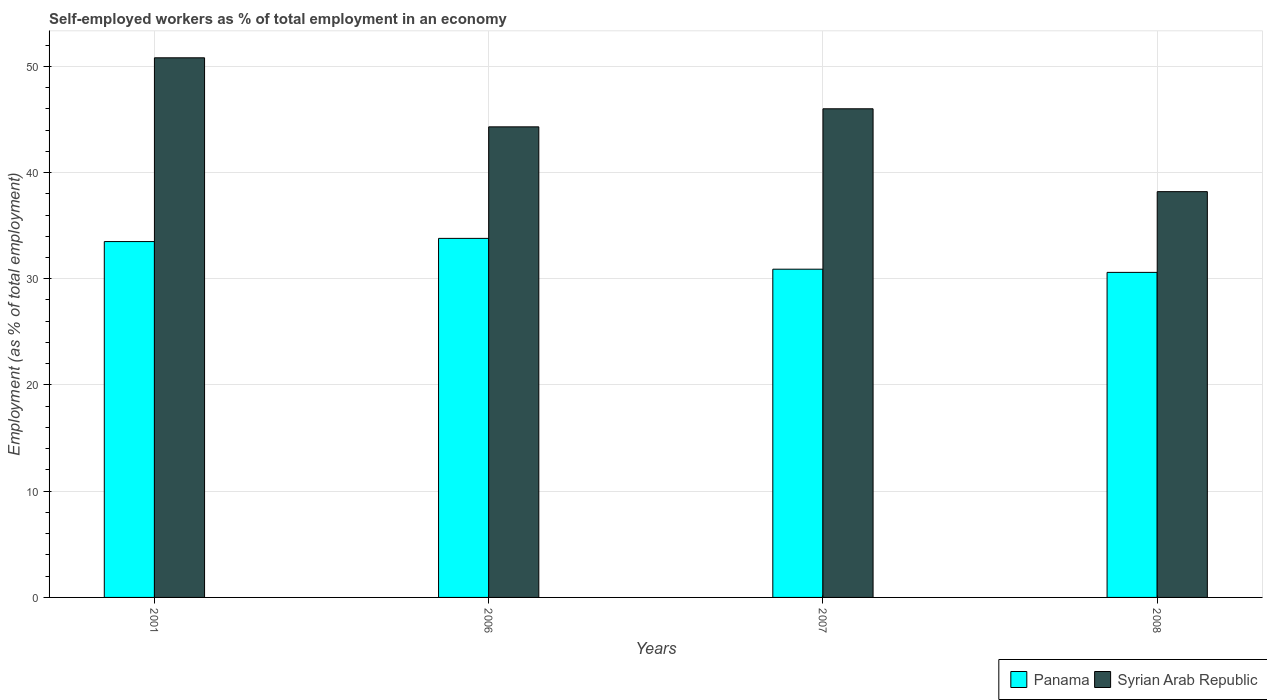How many different coloured bars are there?
Make the answer very short. 2. How many groups of bars are there?
Provide a succinct answer. 4. Are the number of bars per tick equal to the number of legend labels?
Provide a succinct answer. Yes. Are the number of bars on each tick of the X-axis equal?
Offer a very short reply. Yes. How many bars are there on the 4th tick from the right?
Provide a succinct answer. 2. In how many cases, is the number of bars for a given year not equal to the number of legend labels?
Make the answer very short. 0. What is the percentage of self-employed workers in Panama in 2008?
Offer a very short reply. 30.6. Across all years, what is the maximum percentage of self-employed workers in Syrian Arab Republic?
Keep it short and to the point. 50.8. Across all years, what is the minimum percentage of self-employed workers in Syrian Arab Republic?
Make the answer very short. 38.2. In which year was the percentage of self-employed workers in Panama maximum?
Your answer should be compact. 2006. What is the total percentage of self-employed workers in Panama in the graph?
Your response must be concise. 128.8. What is the difference between the percentage of self-employed workers in Panama in 2001 and that in 2006?
Your answer should be very brief. -0.3. What is the difference between the percentage of self-employed workers in Syrian Arab Republic in 2007 and the percentage of self-employed workers in Panama in 2006?
Make the answer very short. 12.2. What is the average percentage of self-employed workers in Panama per year?
Give a very brief answer. 32.2. In the year 2007, what is the difference between the percentage of self-employed workers in Syrian Arab Republic and percentage of self-employed workers in Panama?
Keep it short and to the point. 15.1. What is the ratio of the percentage of self-employed workers in Syrian Arab Republic in 2001 to that in 2008?
Offer a terse response. 1.33. Is the difference between the percentage of self-employed workers in Syrian Arab Republic in 2001 and 2006 greater than the difference between the percentage of self-employed workers in Panama in 2001 and 2006?
Ensure brevity in your answer.  Yes. What is the difference between the highest and the second highest percentage of self-employed workers in Panama?
Your answer should be compact. 0.3. What is the difference between the highest and the lowest percentage of self-employed workers in Syrian Arab Republic?
Make the answer very short. 12.6. What does the 2nd bar from the left in 2007 represents?
Make the answer very short. Syrian Arab Republic. What does the 1st bar from the right in 2007 represents?
Give a very brief answer. Syrian Arab Republic. How many years are there in the graph?
Your answer should be compact. 4. What is the difference between two consecutive major ticks on the Y-axis?
Make the answer very short. 10. Are the values on the major ticks of Y-axis written in scientific E-notation?
Provide a short and direct response. No. Does the graph contain any zero values?
Provide a succinct answer. No. Where does the legend appear in the graph?
Ensure brevity in your answer.  Bottom right. What is the title of the graph?
Offer a very short reply. Self-employed workers as % of total employment in an economy. Does "South Asia" appear as one of the legend labels in the graph?
Ensure brevity in your answer.  No. What is the label or title of the Y-axis?
Offer a terse response. Employment (as % of total employment). What is the Employment (as % of total employment) in Panama in 2001?
Provide a succinct answer. 33.5. What is the Employment (as % of total employment) in Syrian Arab Republic in 2001?
Your answer should be compact. 50.8. What is the Employment (as % of total employment) of Panama in 2006?
Provide a short and direct response. 33.8. What is the Employment (as % of total employment) in Syrian Arab Republic in 2006?
Your response must be concise. 44.3. What is the Employment (as % of total employment) of Panama in 2007?
Give a very brief answer. 30.9. What is the Employment (as % of total employment) of Panama in 2008?
Offer a very short reply. 30.6. What is the Employment (as % of total employment) in Syrian Arab Republic in 2008?
Offer a very short reply. 38.2. Across all years, what is the maximum Employment (as % of total employment) of Panama?
Offer a terse response. 33.8. Across all years, what is the maximum Employment (as % of total employment) in Syrian Arab Republic?
Offer a very short reply. 50.8. Across all years, what is the minimum Employment (as % of total employment) in Panama?
Your answer should be compact. 30.6. Across all years, what is the minimum Employment (as % of total employment) of Syrian Arab Republic?
Provide a succinct answer. 38.2. What is the total Employment (as % of total employment) of Panama in the graph?
Provide a succinct answer. 128.8. What is the total Employment (as % of total employment) in Syrian Arab Republic in the graph?
Your response must be concise. 179.3. What is the difference between the Employment (as % of total employment) of Panama in 2001 and that in 2007?
Your response must be concise. 2.6. What is the difference between the Employment (as % of total employment) in Panama in 2001 and that in 2008?
Your answer should be compact. 2.9. What is the difference between the Employment (as % of total employment) in Panama in 2006 and that in 2007?
Offer a terse response. 2.9. What is the difference between the Employment (as % of total employment) of Syrian Arab Republic in 2006 and that in 2007?
Offer a terse response. -1.7. What is the difference between the Employment (as % of total employment) of Syrian Arab Republic in 2007 and that in 2008?
Ensure brevity in your answer.  7.8. What is the difference between the Employment (as % of total employment) in Panama in 2001 and the Employment (as % of total employment) in Syrian Arab Republic in 2008?
Provide a succinct answer. -4.7. What is the difference between the Employment (as % of total employment) of Panama in 2006 and the Employment (as % of total employment) of Syrian Arab Republic in 2007?
Make the answer very short. -12.2. What is the difference between the Employment (as % of total employment) in Panama in 2006 and the Employment (as % of total employment) in Syrian Arab Republic in 2008?
Your answer should be very brief. -4.4. What is the average Employment (as % of total employment) of Panama per year?
Keep it short and to the point. 32.2. What is the average Employment (as % of total employment) of Syrian Arab Republic per year?
Give a very brief answer. 44.83. In the year 2001, what is the difference between the Employment (as % of total employment) of Panama and Employment (as % of total employment) of Syrian Arab Republic?
Provide a short and direct response. -17.3. In the year 2007, what is the difference between the Employment (as % of total employment) in Panama and Employment (as % of total employment) in Syrian Arab Republic?
Give a very brief answer. -15.1. In the year 2008, what is the difference between the Employment (as % of total employment) of Panama and Employment (as % of total employment) of Syrian Arab Republic?
Provide a short and direct response. -7.6. What is the ratio of the Employment (as % of total employment) in Panama in 2001 to that in 2006?
Your answer should be very brief. 0.99. What is the ratio of the Employment (as % of total employment) in Syrian Arab Republic in 2001 to that in 2006?
Your answer should be very brief. 1.15. What is the ratio of the Employment (as % of total employment) of Panama in 2001 to that in 2007?
Offer a terse response. 1.08. What is the ratio of the Employment (as % of total employment) in Syrian Arab Republic in 2001 to that in 2007?
Ensure brevity in your answer.  1.1. What is the ratio of the Employment (as % of total employment) of Panama in 2001 to that in 2008?
Your answer should be compact. 1.09. What is the ratio of the Employment (as % of total employment) of Syrian Arab Republic in 2001 to that in 2008?
Offer a terse response. 1.33. What is the ratio of the Employment (as % of total employment) in Panama in 2006 to that in 2007?
Your response must be concise. 1.09. What is the ratio of the Employment (as % of total employment) of Panama in 2006 to that in 2008?
Make the answer very short. 1.1. What is the ratio of the Employment (as % of total employment) in Syrian Arab Republic in 2006 to that in 2008?
Provide a succinct answer. 1.16. What is the ratio of the Employment (as % of total employment) of Panama in 2007 to that in 2008?
Provide a succinct answer. 1.01. What is the ratio of the Employment (as % of total employment) in Syrian Arab Republic in 2007 to that in 2008?
Provide a succinct answer. 1.2. What is the difference between the highest and the second highest Employment (as % of total employment) in Panama?
Provide a succinct answer. 0.3. What is the difference between the highest and the lowest Employment (as % of total employment) of Syrian Arab Republic?
Keep it short and to the point. 12.6. 